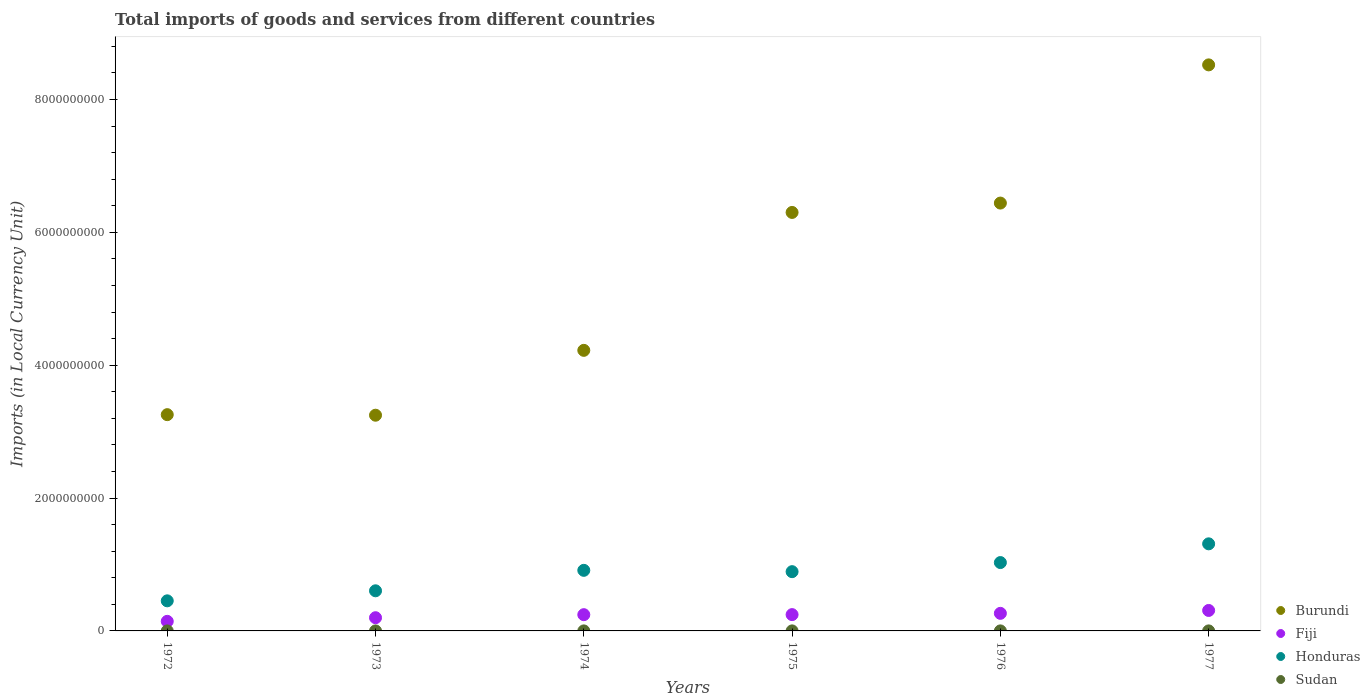How many different coloured dotlines are there?
Provide a succinct answer. 4. What is the Amount of goods and services imports in Burundi in 1977?
Your answer should be compact. 8.52e+09. Across all years, what is the maximum Amount of goods and services imports in Burundi?
Keep it short and to the point. 8.52e+09. Across all years, what is the minimum Amount of goods and services imports in Burundi?
Provide a short and direct response. 3.25e+09. In which year was the Amount of goods and services imports in Burundi maximum?
Offer a terse response. 1977. What is the total Amount of goods and services imports in Honduras in the graph?
Offer a very short reply. 5.20e+09. What is the difference between the Amount of goods and services imports in Fiji in 1973 and that in 1977?
Your response must be concise. -1.09e+08. What is the difference between the Amount of goods and services imports in Fiji in 1973 and the Amount of goods and services imports in Honduras in 1977?
Provide a succinct answer. -1.11e+09. What is the average Amount of goods and services imports in Fiji per year?
Ensure brevity in your answer.  2.34e+08. In the year 1977, what is the difference between the Amount of goods and services imports in Fiji and Amount of goods and services imports in Sudan?
Your answer should be compact. 3.08e+08. In how many years, is the Amount of goods and services imports in Fiji greater than 6800000000 LCU?
Ensure brevity in your answer.  0. What is the ratio of the Amount of goods and services imports in Fiji in 1974 to that in 1977?
Provide a succinct answer. 0.79. Is the Amount of goods and services imports in Sudan in 1974 less than that in 1976?
Your response must be concise. Yes. Is the difference between the Amount of goods and services imports in Fiji in 1972 and 1973 greater than the difference between the Amount of goods and services imports in Sudan in 1972 and 1973?
Keep it short and to the point. No. What is the difference between the highest and the second highest Amount of goods and services imports in Honduras?
Make the answer very short. 2.82e+08. What is the difference between the highest and the lowest Amount of goods and services imports in Sudan?
Provide a short and direct response. 2.90e+05. In how many years, is the Amount of goods and services imports in Burundi greater than the average Amount of goods and services imports in Burundi taken over all years?
Your answer should be very brief. 3. Is the sum of the Amount of goods and services imports in Honduras in 1975 and 1977 greater than the maximum Amount of goods and services imports in Burundi across all years?
Provide a short and direct response. No. Is it the case that in every year, the sum of the Amount of goods and services imports in Burundi and Amount of goods and services imports in Honduras  is greater than the Amount of goods and services imports in Fiji?
Keep it short and to the point. Yes. Does the Amount of goods and services imports in Burundi monotonically increase over the years?
Offer a terse response. No. Is the Amount of goods and services imports in Sudan strictly greater than the Amount of goods and services imports in Honduras over the years?
Provide a short and direct response. No. How many years are there in the graph?
Give a very brief answer. 6. What is the difference between two consecutive major ticks on the Y-axis?
Your answer should be very brief. 2.00e+09. Does the graph contain any zero values?
Your answer should be very brief. No. Where does the legend appear in the graph?
Offer a terse response. Bottom right. How are the legend labels stacked?
Keep it short and to the point. Vertical. What is the title of the graph?
Your answer should be compact. Total imports of goods and services from different countries. What is the label or title of the Y-axis?
Offer a terse response. Imports (in Local Currency Unit). What is the Imports (in Local Currency Unit) of Burundi in 1972?
Give a very brief answer. 3.26e+09. What is the Imports (in Local Currency Unit) in Fiji in 1972?
Keep it short and to the point. 1.44e+08. What is the Imports (in Local Currency Unit) in Honduras in 1972?
Your answer should be very brief. 4.53e+08. What is the Imports (in Local Currency Unit) of Sudan in 1972?
Provide a short and direct response. 1.44e+05. What is the Imports (in Local Currency Unit) of Burundi in 1973?
Your answer should be very brief. 3.25e+09. What is the Imports (in Local Currency Unit) in Fiji in 1973?
Provide a short and direct response. 1.99e+08. What is the Imports (in Local Currency Unit) of Honduras in 1973?
Keep it short and to the point. 6.04e+08. What is the Imports (in Local Currency Unit) in Sudan in 1973?
Keep it short and to the point. 1.82e+05. What is the Imports (in Local Currency Unit) of Burundi in 1974?
Make the answer very short. 4.22e+09. What is the Imports (in Local Currency Unit) in Fiji in 1974?
Ensure brevity in your answer.  2.45e+08. What is the Imports (in Local Currency Unit) in Honduras in 1974?
Offer a terse response. 9.12e+08. What is the Imports (in Local Currency Unit) in Sudan in 1974?
Your answer should be compact. 2.86e+05. What is the Imports (in Local Currency Unit) of Burundi in 1975?
Provide a short and direct response. 6.30e+09. What is the Imports (in Local Currency Unit) of Fiji in 1975?
Make the answer very short. 2.45e+08. What is the Imports (in Local Currency Unit) of Honduras in 1975?
Keep it short and to the point. 8.92e+08. What is the Imports (in Local Currency Unit) in Sudan in 1975?
Your response must be concise. 3.81e+05. What is the Imports (in Local Currency Unit) in Burundi in 1976?
Your answer should be very brief. 6.44e+09. What is the Imports (in Local Currency Unit) of Fiji in 1976?
Give a very brief answer. 2.65e+08. What is the Imports (in Local Currency Unit) in Honduras in 1976?
Ensure brevity in your answer.  1.03e+09. What is the Imports (in Local Currency Unit) in Sudan in 1976?
Provide a succinct answer. 4.01e+05. What is the Imports (in Local Currency Unit) in Burundi in 1977?
Make the answer very short. 8.52e+09. What is the Imports (in Local Currency Unit) of Fiji in 1977?
Offer a terse response. 3.08e+08. What is the Imports (in Local Currency Unit) of Honduras in 1977?
Provide a short and direct response. 1.31e+09. What is the Imports (in Local Currency Unit) of Sudan in 1977?
Offer a very short reply. 4.34e+05. Across all years, what is the maximum Imports (in Local Currency Unit) in Burundi?
Offer a terse response. 8.52e+09. Across all years, what is the maximum Imports (in Local Currency Unit) in Fiji?
Give a very brief answer. 3.08e+08. Across all years, what is the maximum Imports (in Local Currency Unit) in Honduras?
Your answer should be compact. 1.31e+09. Across all years, what is the maximum Imports (in Local Currency Unit) of Sudan?
Offer a very short reply. 4.34e+05. Across all years, what is the minimum Imports (in Local Currency Unit) in Burundi?
Provide a succinct answer. 3.25e+09. Across all years, what is the minimum Imports (in Local Currency Unit) of Fiji?
Your answer should be very brief. 1.44e+08. Across all years, what is the minimum Imports (in Local Currency Unit) of Honduras?
Your answer should be very brief. 4.53e+08. Across all years, what is the minimum Imports (in Local Currency Unit) in Sudan?
Provide a short and direct response. 1.44e+05. What is the total Imports (in Local Currency Unit) in Burundi in the graph?
Your response must be concise. 3.20e+1. What is the total Imports (in Local Currency Unit) of Fiji in the graph?
Offer a terse response. 1.41e+09. What is the total Imports (in Local Currency Unit) of Honduras in the graph?
Offer a very short reply. 5.20e+09. What is the total Imports (in Local Currency Unit) in Sudan in the graph?
Your response must be concise. 1.83e+06. What is the difference between the Imports (in Local Currency Unit) of Burundi in 1972 and that in 1973?
Make the answer very short. 8.30e+06. What is the difference between the Imports (in Local Currency Unit) of Fiji in 1972 and that in 1973?
Your answer should be very brief. -5.46e+07. What is the difference between the Imports (in Local Currency Unit) of Honduras in 1972 and that in 1973?
Make the answer very short. -1.51e+08. What is the difference between the Imports (in Local Currency Unit) in Sudan in 1972 and that in 1973?
Your response must be concise. -3.83e+04. What is the difference between the Imports (in Local Currency Unit) of Burundi in 1972 and that in 1974?
Provide a short and direct response. -9.68e+08. What is the difference between the Imports (in Local Currency Unit) in Fiji in 1972 and that in 1974?
Your answer should be compact. -1.00e+08. What is the difference between the Imports (in Local Currency Unit) of Honduras in 1972 and that in 1974?
Ensure brevity in your answer.  -4.59e+08. What is the difference between the Imports (in Local Currency Unit) of Sudan in 1972 and that in 1974?
Provide a short and direct response. -1.42e+05. What is the difference between the Imports (in Local Currency Unit) of Burundi in 1972 and that in 1975?
Ensure brevity in your answer.  -3.04e+09. What is the difference between the Imports (in Local Currency Unit) in Fiji in 1972 and that in 1975?
Offer a very short reply. -1.01e+08. What is the difference between the Imports (in Local Currency Unit) of Honduras in 1972 and that in 1975?
Make the answer very short. -4.39e+08. What is the difference between the Imports (in Local Currency Unit) in Sudan in 1972 and that in 1975?
Give a very brief answer. -2.37e+05. What is the difference between the Imports (in Local Currency Unit) in Burundi in 1972 and that in 1976?
Provide a short and direct response. -3.19e+09. What is the difference between the Imports (in Local Currency Unit) of Fiji in 1972 and that in 1976?
Provide a succinct answer. -1.20e+08. What is the difference between the Imports (in Local Currency Unit) of Honduras in 1972 and that in 1976?
Offer a terse response. -5.76e+08. What is the difference between the Imports (in Local Currency Unit) of Sudan in 1972 and that in 1976?
Give a very brief answer. -2.57e+05. What is the difference between the Imports (in Local Currency Unit) in Burundi in 1972 and that in 1977?
Keep it short and to the point. -5.27e+09. What is the difference between the Imports (in Local Currency Unit) of Fiji in 1972 and that in 1977?
Offer a very short reply. -1.64e+08. What is the difference between the Imports (in Local Currency Unit) of Honduras in 1972 and that in 1977?
Provide a succinct answer. -8.58e+08. What is the difference between the Imports (in Local Currency Unit) in Sudan in 1972 and that in 1977?
Provide a short and direct response. -2.90e+05. What is the difference between the Imports (in Local Currency Unit) of Burundi in 1973 and that in 1974?
Make the answer very short. -9.76e+08. What is the difference between the Imports (in Local Currency Unit) of Fiji in 1973 and that in 1974?
Your response must be concise. -4.58e+07. What is the difference between the Imports (in Local Currency Unit) of Honduras in 1973 and that in 1974?
Ensure brevity in your answer.  -3.08e+08. What is the difference between the Imports (in Local Currency Unit) of Sudan in 1973 and that in 1974?
Provide a short and direct response. -1.03e+05. What is the difference between the Imports (in Local Currency Unit) in Burundi in 1973 and that in 1975?
Make the answer very short. -3.05e+09. What is the difference between the Imports (in Local Currency Unit) in Fiji in 1973 and that in 1975?
Make the answer very short. -4.66e+07. What is the difference between the Imports (in Local Currency Unit) in Honduras in 1973 and that in 1975?
Keep it short and to the point. -2.88e+08. What is the difference between the Imports (in Local Currency Unit) of Sudan in 1973 and that in 1975?
Your answer should be very brief. -1.99e+05. What is the difference between the Imports (in Local Currency Unit) of Burundi in 1973 and that in 1976?
Offer a very short reply. -3.19e+09. What is the difference between the Imports (in Local Currency Unit) in Fiji in 1973 and that in 1976?
Give a very brief answer. -6.58e+07. What is the difference between the Imports (in Local Currency Unit) in Honduras in 1973 and that in 1976?
Offer a terse response. -4.25e+08. What is the difference between the Imports (in Local Currency Unit) in Sudan in 1973 and that in 1976?
Offer a terse response. -2.18e+05. What is the difference between the Imports (in Local Currency Unit) of Burundi in 1973 and that in 1977?
Your answer should be compact. -5.27e+09. What is the difference between the Imports (in Local Currency Unit) of Fiji in 1973 and that in 1977?
Offer a terse response. -1.09e+08. What is the difference between the Imports (in Local Currency Unit) of Honduras in 1973 and that in 1977?
Ensure brevity in your answer.  -7.07e+08. What is the difference between the Imports (in Local Currency Unit) of Sudan in 1973 and that in 1977?
Ensure brevity in your answer.  -2.52e+05. What is the difference between the Imports (in Local Currency Unit) in Burundi in 1974 and that in 1975?
Your answer should be compact. -2.08e+09. What is the difference between the Imports (in Local Currency Unit) in Fiji in 1974 and that in 1975?
Offer a terse response. -8.00e+05. What is the difference between the Imports (in Local Currency Unit) in Honduras in 1974 and that in 1975?
Keep it short and to the point. 2.00e+07. What is the difference between the Imports (in Local Currency Unit) of Sudan in 1974 and that in 1975?
Provide a short and direct response. -9.56e+04. What is the difference between the Imports (in Local Currency Unit) of Burundi in 1974 and that in 1976?
Your answer should be compact. -2.22e+09. What is the difference between the Imports (in Local Currency Unit) of Fiji in 1974 and that in 1976?
Your answer should be very brief. -2.00e+07. What is the difference between the Imports (in Local Currency Unit) of Honduras in 1974 and that in 1976?
Your answer should be compact. -1.17e+08. What is the difference between the Imports (in Local Currency Unit) in Sudan in 1974 and that in 1976?
Provide a short and direct response. -1.15e+05. What is the difference between the Imports (in Local Currency Unit) in Burundi in 1974 and that in 1977?
Make the answer very short. -4.30e+09. What is the difference between the Imports (in Local Currency Unit) in Fiji in 1974 and that in 1977?
Provide a succinct answer. -6.35e+07. What is the difference between the Imports (in Local Currency Unit) of Honduras in 1974 and that in 1977?
Your answer should be very brief. -3.99e+08. What is the difference between the Imports (in Local Currency Unit) of Sudan in 1974 and that in 1977?
Ensure brevity in your answer.  -1.48e+05. What is the difference between the Imports (in Local Currency Unit) in Burundi in 1975 and that in 1976?
Your response must be concise. -1.41e+08. What is the difference between the Imports (in Local Currency Unit) of Fiji in 1975 and that in 1976?
Your answer should be compact. -1.92e+07. What is the difference between the Imports (in Local Currency Unit) of Honduras in 1975 and that in 1976?
Ensure brevity in your answer.  -1.37e+08. What is the difference between the Imports (in Local Currency Unit) in Sudan in 1975 and that in 1976?
Give a very brief answer. -1.95e+04. What is the difference between the Imports (in Local Currency Unit) of Burundi in 1975 and that in 1977?
Ensure brevity in your answer.  -2.22e+09. What is the difference between the Imports (in Local Currency Unit) in Fiji in 1975 and that in 1977?
Provide a short and direct response. -6.27e+07. What is the difference between the Imports (in Local Currency Unit) of Honduras in 1975 and that in 1977?
Provide a succinct answer. -4.19e+08. What is the difference between the Imports (in Local Currency Unit) in Sudan in 1975 and that in 1977?
Your answer should be very brief. -5.29e+04. What is the difference between the Imports (in Local Currency Unit) in Burundi in 1976 and that in 1977?
Give a very brief answer. -2.08e+09. What is the difference between the Imports (in Local Currency Unit) of Fiji in 1976 and that in 1977?
Make the answer very short. -4.35e+07. What is the difference between the Imports (in Local Currency Unit) in Honduras in 1976 and that in 1977?
Keep it short and to the point. -2.82e+08. What is the difference between the Imports (in Local Currency Unit) in Sudan in 1976 and that in 1977?
Make the answer very short. -3.34e+04. What is the difference between the Imports (in Local Currency Unit) of Burundi in 1972 and the Imports (in Local Currency Unit) of Fiji in 1973?
Your response must be concise. 3.06e+09. What is the difference between the Imports (in Local Currency Unit) of Burundi in 1972 and the Imports (in Local Currency Unit) of Honduras in 1973?
Provide a short and direct response. 2.65e+09. What is the difference between the Imports (in Local Currency Unit) of Burundi in 1972 and the Imports (in Local Currency Unit) of Sudan in 1973?
Ensure brevity in your answer.  3.26e+09. What is the difference between the Imports (in Local Currency Unit) of Fiji in 1972 and the Imports (in Local Currency Unit) of Honduras in 1973?
Keep it short and to the point. -4.60e+08. What is the difference between the Imports (in Local Currency Unit) in Fiji in 1972 and the Imports (in Local Currency Unit) in Sudan in 1973?
Offer a very short reply. 1.44e+08. What is the difference between the Imports (in Local Currency Unit) in Honduras in 1972 and the Imports (in Local Currency Unit) in Sudan in 1973?
Make the answer very short. 4.53e+08. What is the difference between the Imports (in Local Currency Unit) in Burundi in 1972 and the Imports (in Local Currency Unit) in Fiji in 1974?
Your response must be concise. 3.01e+09. What is the difference between the Imports (in Local Currency Unit) of Burundi in 1972 and the Imports (in Local Currency Unit) of Honduras in 1974?
Keep it short and to the point. 2.34e+09. What is the difference between the Imports (in Local Currency Unit) of Burundi in 1972 and the Imports (in Local Currency Unit) of Sudan in 1974?
Make the answer very short. 3.26e+09. What is the difference between the Imports (in Local Currency Unit) in Fiji in 1972 and the Imports (in Local Currency Unit) in Honduras in 1974?
Your response must be concise. -7.68e+08. What is the difference between the Imports (in Local Currency Unit) in Fiji in 1972 and the Imports (in Local Currency Unit) in Sudan in 1974?
Your response must be concise. 1.44e+08. What is the difference between the Imports (in Local Currency Unit) in Honduras in 1972 and the Imports (in Local Currency Unit) in Sudan in 1974?
Give a very brief answer. 4.53e+08. What is the difference between the Imports (in Local Currency Unit) of Burundi in 1972 and the Imports (in Local Currency Unit) of Fiji in 1975?
Make the answer very short. 3.01e+09. What is the difference between the Imports (in Local Currency Unit) in Burundi in 1972 and the Imports (in Local Currency Unit) in Honduras in 1975?
Ensure brevity in your answer.  2.36e+09. What is the difference between the Imports (in Local Currency Unit) in Burundi in 1972 and the Imports (in Local Currency Unit) in Sudan in 1975?
Offer a terse response. 3.26e+09. What is the difference between the Imports (in Local Currency Unit) of Fiji in 1972 and the Imports (in Local Currency Unit) of Honduras in 1975?
Your answer should be compact. -7.48e+08. What is the difference between the Imports (in Local Currency Unit) in Fiji in 1972 and the Imports (in Local Currency Unit) in Sudan in 1975?
Give a very brief answer. 1.44e+08. What is the difference between the Imports (in Local Currency Unit) of Honduras in 1972 and the Imports (in Local Currency Unit) of Sudan in 1975?
Provide a short and direct response. 4.53e+08. What is the difference between the Imports (in Local Currency Unit) in Burundi in 1972 and the Imports (in Local Currency Unit) in Fiji in 1976?
Give a very brief answer. 2.99e+09. What is the difference between the Imports (in Local Currency Unit) of Burundi in 1972 and the Imports (in Local Currency Unit) of Honduras in 1976?
Provide a short and direct response. 2.23e+09. What is the difference between the Imports (in Local Currency Unit) of Burundi in 1972 and the Imports (in Local Currency Unit) of Sudan in 1976?
Your answer should be very brief. 3.26e+09. What is the difference between the Imports (in Local Currency Unit) in Fiji in 1972 and the Imports (in Local Currency Unit) in Honduras in 1976?
Keep it short and to the point. -8.85e+08. What is the difference between the Imports (in Local Currency Unit) of Fiji in 1972 and the Imports (in Local Currency Unit) of Sudan in 1976?
Keep it short and to the point. 1.44e+08. What is the difference between the Imports (in Local Currency Unit) in Honduras in 1972 and the Imports (in Local Currency Unit) in Sudan in 1976?
Give a very brief answer. 4.53e+08. What is the difference between the Imports (in Local Currency Unit) in Burundi in 1972 and the Imports (in Local Currency Unit) in Fiji in 1977?
Provide a succinct answer. 2.95e+09. What is the difference between the Imports (in Local Currency Unit) in Burundi in 1972 and the Imports (in Local Currency Unit) in Honduras in 1977?
Make the answer very short. 1.94e+09. What is the difference between the Imports (in Local Currency Unit) of Burundi in 1972 and the Imports (in Local Currency Unit) of Sudan in 1977?
Your response must be concise. 3.26e+09. What is the difference between the Imports (in Local Currency Unit) in Fiji in 1972 and the Imports (in Local Currency Unit) in Honduras in 1977?
Give a very brief answer. -1.17e+09. What is the difference between the Imports (in Local Currency Unit) in Fiji in 1972 and the Imports (in Local Currency Unit) in Sudan in 1977?
Offer a terse response. 1.44e+08. What is the difference between the Imports (in Local Currency Unit) of Honduras in 1972 and the Imports (in Local Currency Unit) of Sudan in 1977?
Ensure brevity in your answer.  4.53e+08. What is the difference between the Imports (in Local Currency Unit) of Burundi in 1973 and the Imports (in Local Currency Unit) of Fiji in 1974?
Give a very brief answer. 3.00e+09. What is the difference between the Imports (in Local Currency Unit) of Burundi in 1973 and the Imports (in Local Currency Unit) of Honduras in 1974?
Make the answer very short. 2.34e+09. What is the difference between the Imports (in Local Currency Unit) of Burundi in 1973 and the Imports (in Local Currency Unit) of Sudan in 1974?
Your response must be concise. 3.25e+09. What is the difference between the Imports (in Local Currency Unit) of Fiji in 1973 and the Imports (in Local Currency Unit) of Honduras in 1974?
Your answer should be compact. -7.13e+08. What is the difference between the Imports (in Local Currency Unit) in Fiji in 1973 and the Imports (in Local Currency Unit) in Sudan in 1974?
Your response must be concise. 1.99e+08. What is the difference between the Imports (in Local Currency Unit) in Honduras in 1973 and the Imports (in Local Currency Unit) in Sudan in 1974?
Offer a terse response. 6.04e+08. What is the difference between the Imports (in Local Currency Unit) of Burundi in 1973 and the Imports (in Local Currency Unit) of Fiji in 1975?
Keep it short and to the point. 3.00e+09. What is the difference between the Imports (in Local Currency Unit) of Burundi in 1973 and the Imports (in Local Currency Unit) of Honduras in 1975?
Keep it short and to the point. 2.36e+09. What is the difference between the Imports (in Local Currency Unit) of Burundi in 1973 and the Imports (in Local Currency Unit) of Sudan in 1975?
Your answer should be very brief. 3.25e+09. What is the difference between the Imports (in Local Currency Unit) in Fiji in 1973 and the Imports (in Local Currency Unit) in Honduras in 1975?
Keep it short and to the point. -6.93e+08. What is the difference between the Imports (in Local Currency Unit) of Fiji in 1973 and the Imports (in Local Currency Unit) of Sudan in 1975?
Offer a terse response. 1.98e+08. What is the difference between the Imports (in Local Currency Unit) in Honduras in 1973 and the Imports (in Local Currency Unit) in Sudan in 1975?
Your response must be concise. 6.04e+08. What is the difference between the Imports (in Local Currency Unit) of Burundi in 1973 and the Imports (in Local Currency Unit) of Fiji in 1976?
Your answer should be compact. 2.98e+09. What is the difference between the Imports (in Local Currency Unit) of Burundi in 1973 and the Imports (in Local Currency Unit) of Honduras in 1976?
Provide a short and direct response. 2.22e+09. What is the difference between the Imports (in Local Currency Unit) of Burundi in 1973 and the Imports (in Local Currency Unit) of Sudan in 1976?
Offer a terse response. 3.25e+09. What is the difference between the Imports (in Local Currency Unit) of Fiji in 1973 and the Imports (in Local Currency Unit) of Honduras in 1976?
Offer a terse response. -8.30e+08. What is the difference between the Imports (in Local Currency Unit) in Fiji in 1973 and the Imports (in Local Currency Unit) in Sudan in 1976?
Your answer should be compact. 1.98e+08. What is the difference between the Imports (in Local Currency Unit) of Honduras in 1973 and the Imports (in Local Currency Unit) of Sudan in 1976?
Provide a succinct answer. 6.04e+08. What is the difference between the Imports (in Local Currency Unit) in Burundi in 1973 and the Imports (in Local Currency Unit) in Fiji in 1977?
Your response must be concise. 2.94e+09. What is the difference between the Imports (in Local Currency Unit) of Burundi in 1973 and the Imports (in Local Currency Unit) of Honduras in 1977?
Your answer should be compact. 1.94e+09. What is the difference between the Imports (in Local Currency Unit) of Burundi in 1973 and the Imports (in Local Currency Unit) of Sudan in 1977?
Provide a succinct answer. 3.25e+09. What is the difference between the Imports (in Local Currency Unit) of Fiji in 1973 and the Imports (in Local Currency Unit) of Honduras in 1977?
Provide a succinct answer. -1.11e+09. What is the difference between the Imports (in Local Currency Unit) in Fiji in 1973 and the Imports (in Local Currency Unit) in Sudan in 1977?
Keep it short and to the point. 1.98e+08. What is the difference between the Imports (in Local Currency Unit) of Honduras in 1973 and the Imports (in Local Currency Unit) of Sudan in 1977?
Provide a succinct answer. 6.04e+08. What is the difference between the Imports (in Local Currency Unit) of Burundi in 1974 and the Imports (in Local Currency Unit) of Fiji in 1975?
Your response must be concise. 3.98e+09. What is the difference between the Imports (in Local Currency Unit) of Burundi in 1974 and the Imports (in Local Currency Unit) of Honduras in 1975?
Keep it short and to the point. 3.33e+09. What is the difference between the Imports (in Local Currency Unit) in Burundi in 1974 and the Imports (in Local Currency Unit) in Sudan in 1975?
Offer a terse response. 4.22e+09. What is the difference between the Imports (in Local Currency Unit) of Fiji in 1974 and the Imports (in Local Currency Unit) of Honduras in 1975?
Your response must be concise. -6.47e+08. What is the difference between the Imports (in Local Currency Unit) of Fiji in 1974 and the Imports (in Local Currency Unit) of Sudan in 1975?
Ensure brevity in your answer.  2.44e+08. What is the difference between the Imports (in Local Currency Unit) of Honduras in 1974 and the Imports (in Local Currency Unit) of Sudan in 1975?
Make the answer very short. 9.12e+08. What is the difference between the Imports (in Local Currency Unit) in Burundi in 1974 and the Imports (in Local Currency Unit) in Fiji in 1976?
Make the answer very short. 3.96e+09. What is the difference between the Imports (in Local Currency Unit) in Burundi in 1974 and the Imports (in Local Currency Unit) in Honduras in 1976?
Provide a succinct answer. 3.19e+09. What is the difference between the Imports (in Local Currency Unit) of Burundi in 1974 and the Imports (in Local Currency Unit) of Sudan in 1976?
Provide a succinct answer. 4.22e+09. What is the difference between the Imports (in Local Currency Unit) of Fiji in 1974 and the Imports (in Local Currency Unit) of Honduras in 1976?
Offer a terse response. -7.84e+08. What is the difference between the Imports (in Local Currency Unit) of Fiji in 1974 and the Imports (in Local Currency Unit) of Sudan in 1976?
Your response must be concise. 2.44e+08. What is the difference between the Imports (in Local Currency Unit) of Honduras in 1974 and the Imports (in Local Currency Unit) of Sudan in 1976?
Make the answer very short. 9.12e+08. What is the difference between the Imports (in Local Currency Unit) in Burundi in 1974 and the Imports (in Local Currency Unit) in Fiji in 1977?
Ensure brevity in your answer.  3.92e+09. What is the difference between the Imports (in Local Currency Unit) in Burundi in 1974 and the Imports (in Local Currency Unit) in Honduras in 1977?
Make the answer very short. 2.91e+09. What is the difference between the Imports (in Local Currency Unit) of Burundi in 1974 and the Imports (in Local Currency Unit) of Sudan in 1977?
Ensure brevity in your answer.  4.22e+09. What is the difference between the Imports (in Local Currency Unit) of Fiji in 1974 and the Imports (in Local Currency Unit) of Honduras in 1977?
Offer a very short reply. -1.07e+09. What is the difference between the Imports (in Local Currency Unit) in Fiji in 1974 and the Imports (in Local Currency Unit) in Sudan in 1977?
Keep it short and to the point. 2.44e+08. What is the difference between the Imports (in Local Currency Unit) in Honduras in 1974 and the Imports (in Local Currency Unit) in Sudan in 1977?
Your answer should be compact. 9.12e+08. What is the difference between the Imports (in Local Currency Unit) of Burundi in 1975 and the Imports (in Local Currency Unit) of Fiji in 1976?
Make the answer very short. 6.03e+09. What is the difference between the Imports (in Local Currency Unit) in Burundi in 1975 and the Imports (in Local Currency Unit) in Honduras in 1976?
Give a very brief answer. 5.27e+09. What is the difference between the Imports (in Local Currency Unit) of Burundi in 1975 and the Imports (in Local Currency Unit) of Sudan in 1976?
Offer a terse response. 6.30e+09. What is the difference between the Imports (in Local Currency Unit) in Fiji in 1975 and the Imports (in Local Currency Unit) in Honduras in 1976?
Your answer should be compact. -7.84e+08. What is the difference between the Imports (in Local Currency Unit) in Fiji in 1975 and the Imports (in Local Currency Unit) in Sudan in 1976?
Offer a very short reply. 2.45e+08. What is the difference between the Imports (in Local Currency Unit) in Honduras in 1975 and the Imports (in Local Currency Unit) in Sudan in 1976?
Provide a succinct answer. 8.92e+08. What is the difference between the Imports (in Local Currency Unit) of Burundi in 1975 and the Imports (in Local Currency Unit) of Fiji in 1977?
Provide a short and direct response. 5.99e+09. What is the difference between the Imports (in Local Currency Unit) of Burundi in 1975 and the Imports (in Local Currency Unit) of Honduras in 1977?
Give a very brief answer. 4.99e+09. What is the difference between the Imports (in Local Currency Unit) in Burundi in 1975 and the Imports (in Local Currency Unit) in Sudan in 1977?
Offer a very short reply. 6.30e+09. What is the difference between the Imports (in Local Currency Unit) in Fiji in 1975 and the Imports (in Local Currency Unit) in Honduras in 1977?
Offer a very short reply. -1.07e+09. What is the difference between the Imports (in Local Currency Unit) in Fiji in 1975 and the Imports (in Local Currency Unit) in Sudan in 1977?
Provide a short and direct response. 2.45e+08. What is the difference between the Imports (in Local Currency Unit) in Honduras in 1975 and the Imports (in Local Currency Unit) in Sudan in 1977?
Give a very brief answer. 8.92e+08. What is the difference between the Imports (in Local Currency Unit) of Burundi in 1976 and the Imports (in Local Currency Unit) of Fiji in 1977?
Offer a terse response. 6.13e+09. What is the difference between the Imports (in Local Currency Unit) in Burundi in 1976 and the Imports (in Local Currency Unit) in Honduras in 1977?
Your response must be concise. 5.13e+09. What is the difference between the Imports (in Local Currency Unit) in Burundi in 1976 and the Imports (in Local Currency Unit) in Sudan in 1977?
Your response must be concise. 6.44e+09. What is the difference between the Imports (in Local Currency Unit) in Fiji in 1976 and the Imports (in Local Currency Unit) in Honduras in 1977?
Your response must be concise. -1.05e+09. What is the difference between the Imports (in Local Currency Unit) of Fiji in 1976 and the Imports (in Local Currency Unit) of Sudan in 1977?
Provide a succinct answer. 2.64e+08. What is the difference between the Imports (in Local Currency Unit) in Honduras in 1976 and the Imports (in Local Currency Unit) in Sudan in 1977?
Give a very brief answer. 1.03e+09. What is the average Imports (in Local Currency Unit) of Burundi per year?
Keep it short and to the point. 5.33e+09. What is the average Imports (in Local Currency Unit) in Fiji per year?
Ensure brevity in your answer.  2.34e+08. What is the average Imports (in Local Currency Unit) of Honduras per year?
Keep it short and to the point. 8.67e+08. What is the average Imports (in Local Currency Unit) of Sudan per year?
Give a very brief answer. 3.05e+05. In the year 1972, what is the difference between the Imports (in Local Currency Unit) of Burundi and Imports (in Local Currency Unit) of Fiji?
Your answer should be very brief. 3.11e+09. In the year 1972, what is the difference between the Imports (in Local Currency Unit) of Burundi and Imports (in Local Currency Unit) of Honduras?
Keep it short and to the point. 2.80e+09. In the year 1972, what is the difference between the Imports (in Local Currency Unit) of Burundi and Imports (in Local Currency Unit) of Sudan?
Your answer should be very brief. 3.26e+09. In the year 1972, what is the difference between the Imports (in Local Currency Unit) in Fiji and Imports (in Local Currency Unit) in Honduras?
Make the answer very short. -3.09e+08. In the year 1972, what is the difference between the Imports (in Local Currency Unit) of Fiji and Imports (in Local Currency Unit) of Sudan?
Ensure brevity in your answer.  1.44e+08. In the year 1972, what is the difference between the Imports (in Local Currency Unit) in Honduras and Imports (in Local Currency Unit) in Sudan?
Keep it short and to the point. 4.53e+08. In the year 1973, what is the difference between the Imports (in Local Currency Unit) of Burundi and Imports (in Local Currency Unit) of Fiji?
Give a very brief answer. 3.05e+09. In the year 1973, what is the difference between the Imports (in Local Currency Unit) of Burundi and Imports (in Local Currency Unit) of Honduras?
Give a very brief answer. 2.64e+09. In the year 1973, what is the difference between the Imports (in Local Currency Unit) in Burundi and Imports (in Local Currency Unit) in Sudan?
Ensure brevity in your answer.  3.25e+09. In the year 1973, what is the difference between the Imports (in Local Currency Unit) of Fiji and Imports (in Local Currency Unit) of Honduras?
Your answer should be very brief. -4.05e+08. In the year 1973, what is the difference between the Imports (in Local Currency Unit) in Fiji and Imports (in Local Currency Unit) in Sudan?
Your answer should be compact. 1.99e+08. In the year 1973, what is the difference between the Imports (in Local Currency Unit) of Honduras and Imports (in Local Currency Unit) of Sudan?
Ensure brevity in your answer.  6.04e+08. In the year 1974, what is the difference between the Imports (in Local Currency Unit) in Burundi and Imports (in Local Currency Unit) in Fiji?
Give a very brief answer. 3.98e+09. In the year 1974, what is the difference between the Imports (in Local Currency Unit) in Burundi and Imports (in Local Currency Unit) in Honduras?
Offer a terse response. 3.31e+09. In the year 1974, what is the difference between the Imports (in Local Currency Unit) of Burundi and Imports (in Local Currency Unit) of Sudan?
Provide a short and direct response. 4.22e+09. In the year 1974, what is the difference between the Imports (in Local Currency Unit) in Fiji and Imports (in Local Currency Unit) in Honduras?
Give a very brief answer. -6.67e+08. In the year 1974, what is the difference between the Imports (in Local Currency Unit) in Fiji and Imports (in Local Currency Unit) in Sudan?
Give a very brief answer. 2.44e+08. In the year 1974, what is the difference between the Imports (in Local Currency Unit) in Honduras and Imports (in Local Currency Unit) in Sudan?
Provide a short and direct response. 9.12e+08. In the year 1975, what is the difference between the Imports (in Local Currency Unit) in Burundi and Imports (in Local Currency Unit) in Fiji?
Offer a terse response. 6.05e+09. In the year 1975, what is the difference between the Imports (in Local Currency Unit) of Burundi and Imports (in Local Currency Unit) of Honduras?
Provide a short and direct response. 5.41e+09. In the year 1975, what is the difference between the Imports (in Local Currency Unit) in Burundi and Imports (in Local Currency Unit) in Sudan?
Offer a terse response. 6.30e+09. In the year 1975, what is the difference between the Imports (in Local Currency Unit) of Fiji and Imports (in Local Currency Unit) of Honduras?
Your answer should be compact. -6.47e+08. In the year 1975, what is the difference between the Imports (in Local Currency Unit) of Fiji and Imports (in Local Currency Unit) of Sudan?
Offer a very short reply. 2.45e+08. In the year 1975, what is the difference between the Imports (in Local Currency Unit) of Honduras and Imports (in Local Currency Unit) of Sudan?
Your answer should be very brief. 8.92e+08. In the year 1976, what is the difference between the Imports (in Local Currency Unit) in Burundi and Imports (in Local Currency Unit) in Fiji?
Offer a very short reply. 6.18e+09. In the year 1976, what is the difference between the Imports (in Local Currency Unit) of Burundi and Imports (in Local Currency Unit) of Honduras?
Offer a terse response. 5.41e+09. In the year 1976, what is the difference between the Imports (in Local Currency Unit) in Burundi and Imports (in Local Currency Unit) in Sudan?
Give a very brief answer. 6.44e+09. In the year 1976, what is the difference between the Imports (in Local Currency Unit) in Fiji and Imports (in Local Currency Unit) in Honduras?
Provide a succinct answer. -7.64e+08. In the year 1976, what is the difference between the Imports (in Local Currency Unit) in Fiji and Imports (in Local Currency Unit) in Sudan?
Give a very brief answer. 2.64e+08. In the year 1976, what is the difference between the Imports (in Local Currency Unit) in Honduras and Imports (in Local Currency Unit) in Sudan?
Keep it short and to the point. 1.03e+09. In the year 1977, what is the difference between the Imports (in Local Currency Unit) of Burundi and Imports (in Local Currency Unit) of Fiji?
Your answer should be very brief. 8.21e+09. In the year 1977, what is the difference between the Imports (in Local Currency Unit) of Burundi and Imports (in Local Currency Unit) of Honduras?
Ensure brevity in your answer.  7.21e+09. In the year 1977, what is the difference between the Imports (in Local Currency Unit) in Burundi and Imports (in Local Currency Unit) in Sudan?
Provide a succinct answer. 8.52e+09. In the year 1977, what is the difference between the Imports (in Local Currency Unit) of Fiji and Imports (in Local Currency Unit) of Honduras?
Provide a short and direct response. -1.00e+09. In the year 1977, what is the difference between the Imports (in Local Currency Unit) in Fiji and Imports (in Local Currency Unit) in Sudan?
Keep it short and to the point. 3.08e+08. In the year 1977, what is the difference between the Imports (in Local Currency Unit) in Honduras and Imports (in Local Currency Unit) in Sudan?
Give a very brief answer. 1.31e+09. What is the ratio of the Imports (in Local Currency Unit) in Burundi in 1972 to that in 1973?
Keep it short and to the point. 1. What is the ratio of the Imports (in Local Currency Unit) in Fiji in 1972 to that in 1973?
Your answer should be compact. 0.73. What is the ratio of the Imports (in Local Currency Unit) of Honduras in 1972 to that in 1973?
Provide a succinct answer. 0.75. What is the ratio of the Imports (in Local Currency Unit) of Sudan in 1972 to that in 1973?
Offer a very short reply. 0.79. What is the ratio of the Imports (in Local Currency Unit) in Burundi in 1972 to that in 1974?
Offer a very short reply. 0.77. What is the ratio of the Imports (in Local Currency Unit) in Fiji in 1972 to that in 1974?
Ensure brevity in your answer.  0.59. What is the ratio of the Imports (in Local Currency Unit) of Honduras in 1972 to that in 1974?
Provide a succinct answer. 0.5. What is the ratio of the Imports (in Local Currency Unit) of Sudan in 1972 to that in 1974?
Offer a very short reply. 0.5. What is the ratio of the Imports (in Local Currency Unit) of Burundi in 1972 to that in 1975?
Ensure brevity in your answer.  0.52. What is the ratio of the Imports (in Local Currency Unit) in Fiji in 1972 to that in 1975?
Keep it short and to the point. 0.59. What is the ratio of the Imports (in Local Currency Unit) of Honduras in 1972 to that in 1975?
Your answer should be very brief. 0.51. What is the ratio of the Imports (in Local Currency Unit) of Sudan in 1972 to that in 1975?
Provide a succinct answer. 0.38. What is the ratio of the Imports (in Local Currency Unit) in Burundi in 1972 to that in 1976?
Your response must be concise. 0.51. What is the ratio of the Imports (in Local Currency Unit) in Fiji in 1972 to that in 1976?
Provide a succinct answer. 0.55. What is the ratio of the Imports (in Local Currency Unit) of Honduras in 1972 to that in 1976?
Your answer should be very brief. 0.44. What is the ratio of the Imports (in Local Currency Unit) of Sudan in 1972 to that in 1976?
Make the answer very short. 0.36. What is the ratio of the Imports (in Local Currency Unit) in Burundi in 1972 to that in 1977?
Keep it short and to the point. 0.38. What is the ratio of the Imports (in Local Currency Unit) in Fiji in 1972 to that in 1977?
Offer a very short reply. 0.47. What is the ratio of the Imports (in Local Currency Unit) of Honduras in 1972 to that in 1977?
Offer a very short reply. 0.35. What is the ratio of the Imports (in Local Currency Unit) in Sudan in 1972 to that in 1977?
Keep it short and to the point. 0.33. What is the ratio of the Imports (in Local Currency Unit) of Burundi in 1973 to that in 1974?
Offer a very short reply. 0.77. What is the ratio of the Imports (in Local Currency Unit) in Fiji in 1973 to that in 1974?
Offer a terse response. 0.81. What is the ratio of the Imports (in Local Currency Unit) of Honduras in 1973 to that in 1974?
Your response must be concise. 0.66. What is the ratio of the Imports (in Local Currency Unit) of Sudan in 1973 to that in 1974?
Offer a very short reply. 0.64. What is the ratio of the Imports (in Local Currency Unit) in Burundi in 1973 to that in 1975?
Your response must be concise. 0.52. What is the ratio of the Imports (in Local Currency Unit) in Fiji in 1973 to that in 1975?
Give a very brief answer. 0.81. What is the ratio of the Imports (in Local Currency Unit) of Honduras in 1973 to that in 1975?
Offer a terse response. 0.68. What is the ratio of the Imports (in Local Currency Unit) in Sudan in 1973 to that in 1975?
Offer a terse response. 0.48. What is the ratio of the Imports (in Local Currency Unit) of Burundi in 1973 to that in 1976?
Offer a very short reply. 0.5. What is the ratio of the Imports (in Local Currency Unit) in Fiji in 1973 to that in 1976?
Provide a succinct answer. 0.75. What is the ratio of the Imports (in Local Currency Unit) in Honduras in 1973 to that in 1976?
Your answer should be very brief. 0.59. What is the ratio of the Imports (in Local Currency Unit) in Sudan in 1973 to that in 1976?
Your answer should be very brief. 0.46. What is the ratio of the Imports (in Local Currency Unit) of Burundi in 1973 to that in 1977?
Your response must be concise. 0.38. What is the ratio of the Imports (in Local Currency Unit) of Fiji in 1973 to that in 1977?
Keep it short and to the point. 0.65. What is the ratio of the Imports (in Local Currency Unit) in Honduras in 1973 to that in 1977?
Keep it short and to the point. 0.46. What is the ratio of the Imports (in Local Currency Unit) of Sudan in 1973 to that in 1977?
Give a very brief answer. 0.42. What is the ratio of the Imports (in Local Currency Unit) of Burundi in 1974 to that in 1975?
Offer a very short reply. 0.67. What is the ratio of the Imports (in Local Currency Unit) of Honduras in 1974 to that in 1975?
Provide a short and direct response. 1.02. What is the ratio of the Imports (in Local Currency Unit) in Sudan in 1974 to that in 1975?
Your response must be concise. 0.75. What is the ratio of the Imports (in Local Currency Unit) in Burundi in 1974 to that in 1976?
Your answer should be compact. 0.66. What is the ratio of the Imports (in Local Currency Unit) in Fiji in 1974 to that in 1976?
Ensure brevity in your answer.  0.92. What is the ratio of the Imports (in Local Currency Unit) of Honduras in 1974 to that in 1976?
Offer a very short reply. 0.89. What is the ratio of the Imports (in Local Currency Unit) in Sudan in 1974 to that in 1976?
Provide a short and direct response. 0.71. What is the ratio of the Imports (in Local Currency Unit) of Burundi in 1974 to that in 1977?
Provide a short and direct response. 0.5. What is the ratio of the Imports (in Local Currency Unit) of Fiji in 1974 to that in 1977?
Keep it short and to the point. 0.79. What is the ratio of the Imports (in Local Currency Unit) in Honduras in 1974 to that in 1977?
Give a very brief answer. 0.7. What is the ratio of the Imports (in Local Currency Unit) in Sudan in 1974 to that in 1977?
Keep it short and to the point. 0.66. What is the ratio of the Imports (in Local Currency Unit) in Burundi in 1975 to that in 1976?
Your response must be concise. 0.98. What is the ratio of the Imports (in Local Currency Unit) in Fiji in 1975 to that in 1976?
Your response must be concise. 0.93. What is the ratio of the Imports (in Local Currency Unit) of Honduras in 1975 to that in 1976?
Offer a very short reply. 0.87. What is the ratio of the Imports (in Local Currency Unit) in Sudan in 1975 to that in 1976?
Your response must be concise. 0.95. What is the ratio of the Imports (in Local Currency Unit) of Burundi in 1975 to that in 1977?
Your answer should be compact. 0.74. What is the ratio of the Imports (in Local Currency Unit) of Fiji in 1975 to that in 1977?
Make the answer very short. 0.8. What is the ratio of the Imports (in Local Currency Unit) in Honduras in 1975 to that in 1977?
Give a very brief answer. 0.68. What is the ratio of the Imports (in Local Currency Unit) of Sudan in 1975 to that in 1977?
Your answer should be compact. 0.88. What is the ratio of the Imports (in Local Currency Unit) in Burundi in 1976 to that in 1977?
Keep it short and to the point. 0.76. What is the ratio of the Imports (in Local Currency Unit) in Fiji in 1976 to that in 1977?
Keep it short and to the point. 0.86. What is the ratio of the Imports (in Local Currency Unit) of Honduras in 1976 to that in 1977?
Make the answer very short. 0.78. What is the difference between the highest and the second highest Imports (in Local Currency Unit) in Burundi?
Your response must be concise. 2.08e+09. What is the difference between the highest and the second highest Imports (in Local Currency Unit) in Fiji?
Make the answer very short. 4.35e+07. What is the difference between the highest and the second highest Imports (in Local Currency Unit) in Honduras?
Provide a succinct answer. 2.82e+08. What is the difference between the highest and the second highest Imports (in Local Currency Unit) of Sudan?
Offer a terse response. 3.34e+04. What is the difference between the highest and the lowest Imports (in Local Currency Unit) in Burundi?
Offer a very short reply. 5.27e+09. What is the difference between the highest and the lowest Imports (in Local Currency Unit) in Fiji?
Make the answer very short. 1.64e+08. What is the difference between the highest and the lowest Imports (in Local Currency Unit) in Honduras?
Offer a terse response. 8.58e+08. What is the difference between the highest and the lowest Imports (in Local Currency Unit) of Sudan?
Ensure brevity in your answer.  2.90e+05. 